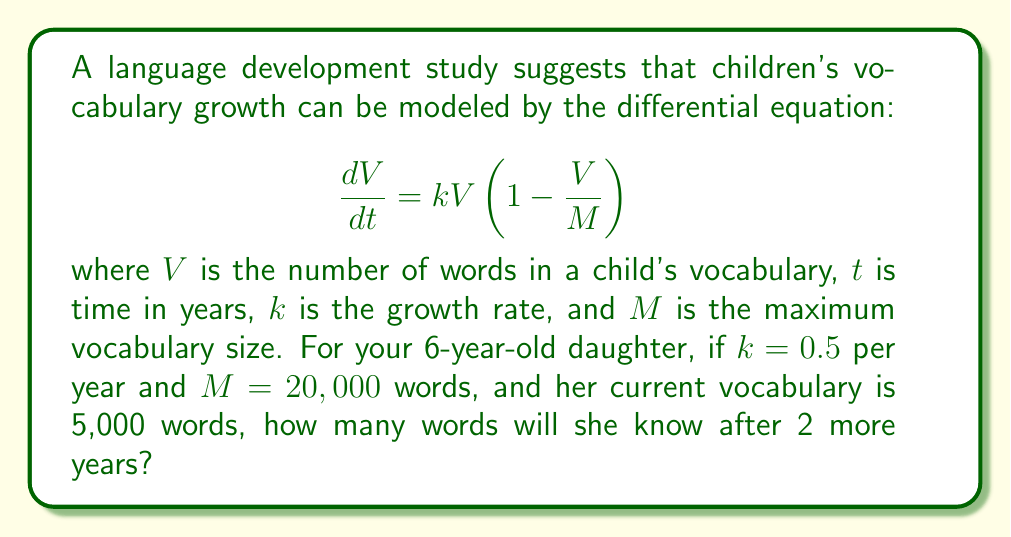Help me with this question. To solve this problem, we need to use the logistic growth model, which is described by the given differential equation. Here's how we can approach it:

1) The general solution to this logistic differential equation is:

   $$V(t) = \frac{M}{1 + (\frac{M}{V_0} - 1)e^{-kt}}$$

   where $V_0$ is the initial vocabulary size.

2) We're given:
   - $k = 0.5$ per year
   - $M = 20,000$ words
   - $V_0 = 5,000$ words (current vocabulary)
   - We need to find $V(2)$ (vocabulary after 2 years)

3) Let's substitute these values into our equation:

   $$V(2) = \frac{20000}{1 + (\frac{20000}{5000} - 1)e^{-0.5 \cdot 2}}$$

4) Simplify:
   $$V(2) = \frac{20000}{1 + (4 - 1)e^{-1}}$$
   $$V(2) = \frac{20000}{1 + 3e^{-1}}$$

5) Calculate $e^{-1} \approx 0.3679$:
   $$V(2) = \frac{20000}{1 + 3(0.3679)}$$
   $$V(2) = \frac{20000}{2.1037}$$

6) Solve:
   $$V(2) \approx 9507.25$$

7) Since we're dealing with whole words, we round to the nearest integer:
   $$V(2) \approx 9507 \text{ words}$$
Answer: After 2 years, your daughter's vocabulary is expected to grow to approximately 9,507 words. 